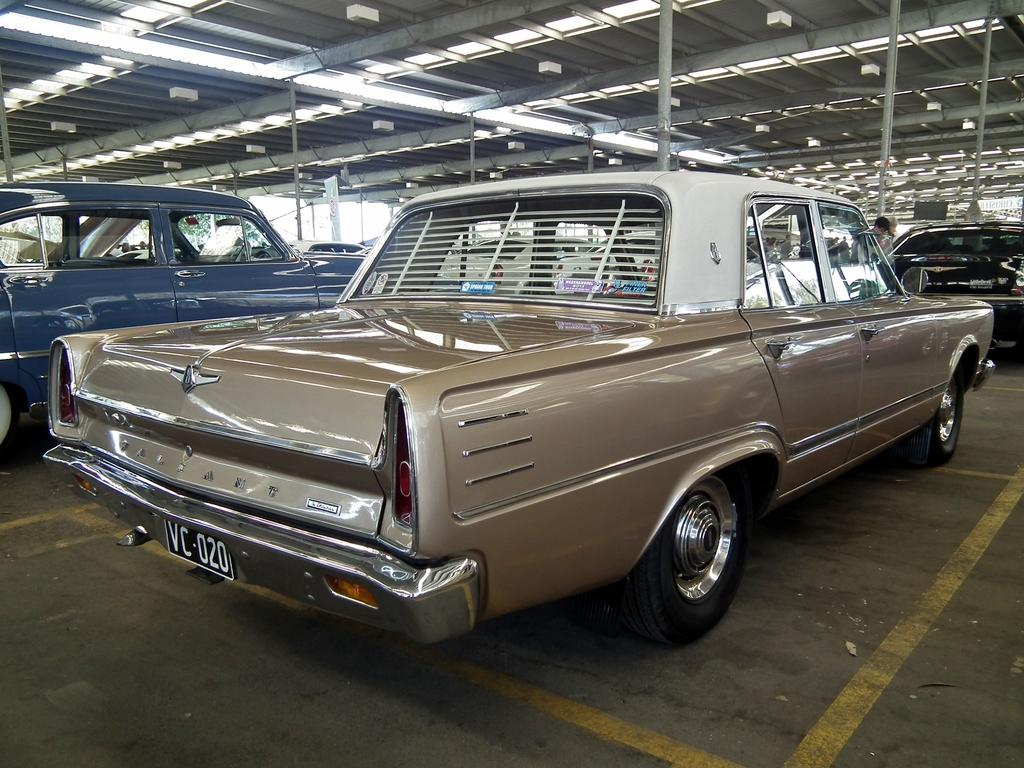What is present in the image? There are vehicles in the image. Can you describe one of the vehicles? One vehicle is in light brown color. What can be seen in the background of the image? There is a person standing in the background, along with poles and lights. What color is the roof in the image? The roof is in white color. How many ladybugs can be seen crawling on the light brown vehicle in the image? There are no ladybugs present in the image; it only features vehicles, a person, poles, lights, and a roof. 